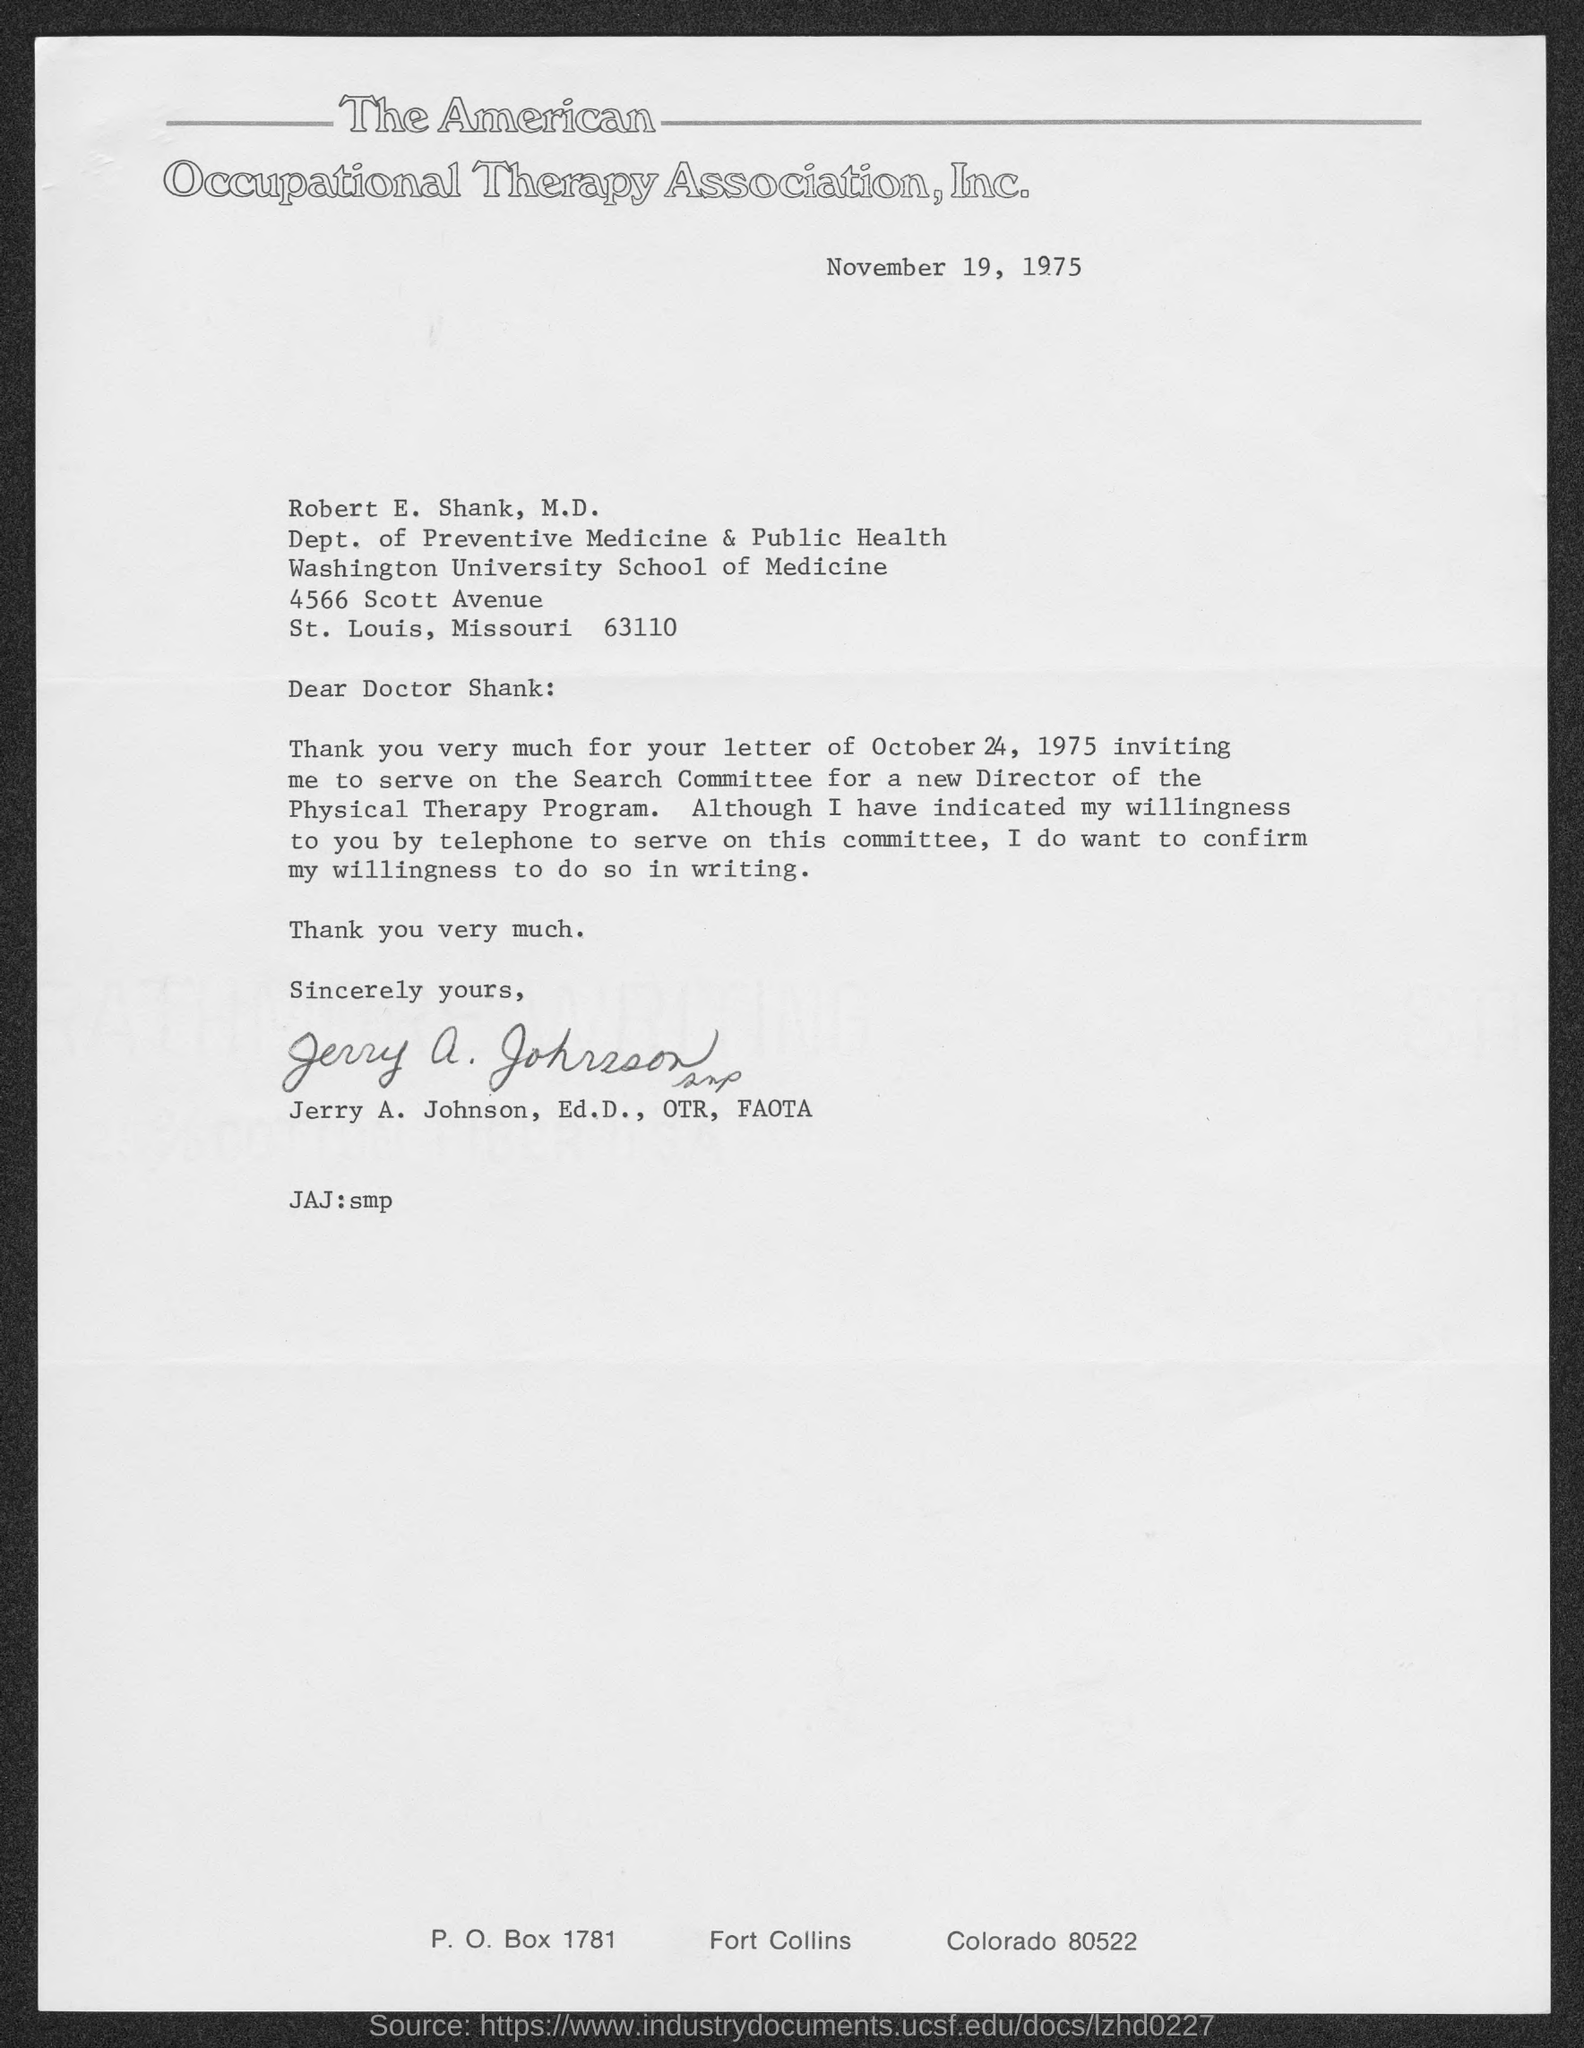Point out several critical features in this image. The letter is addressed to Robert E. Shank, M.D. The postal code of the state of Missouri is 63110. The date on which the letter is dated is November 19, 1975. 